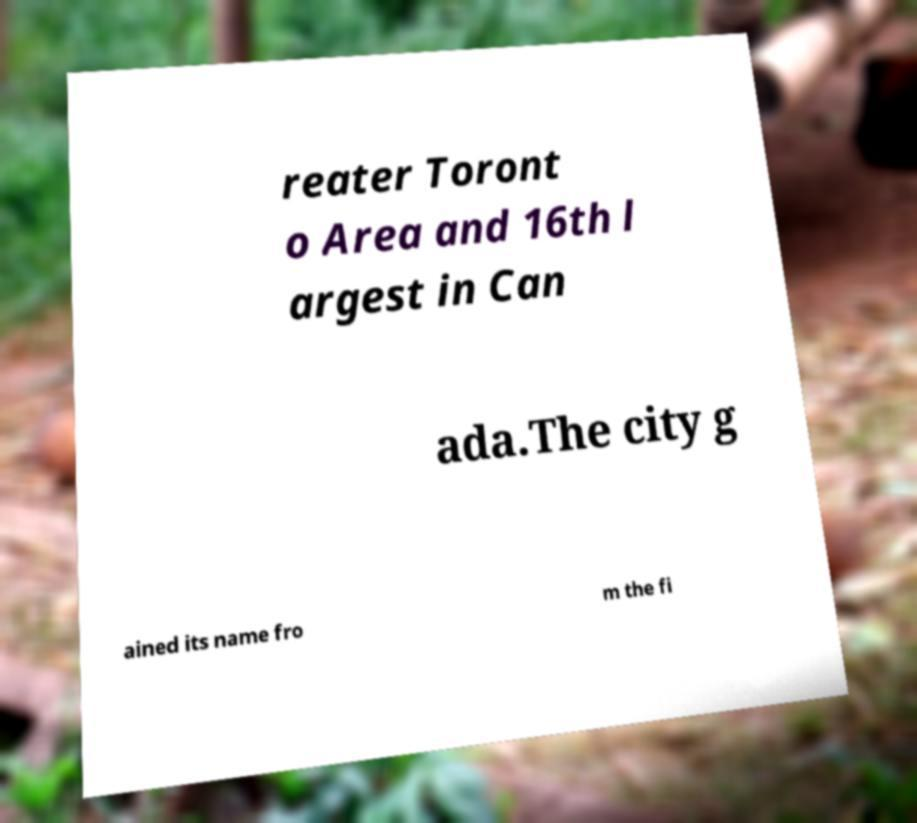For documentation purposes, I need the text within this image transcribed. Could you provide that? reater Toront o Area and 16th l argest in Can ada.The city g ained its name fro m the fi 